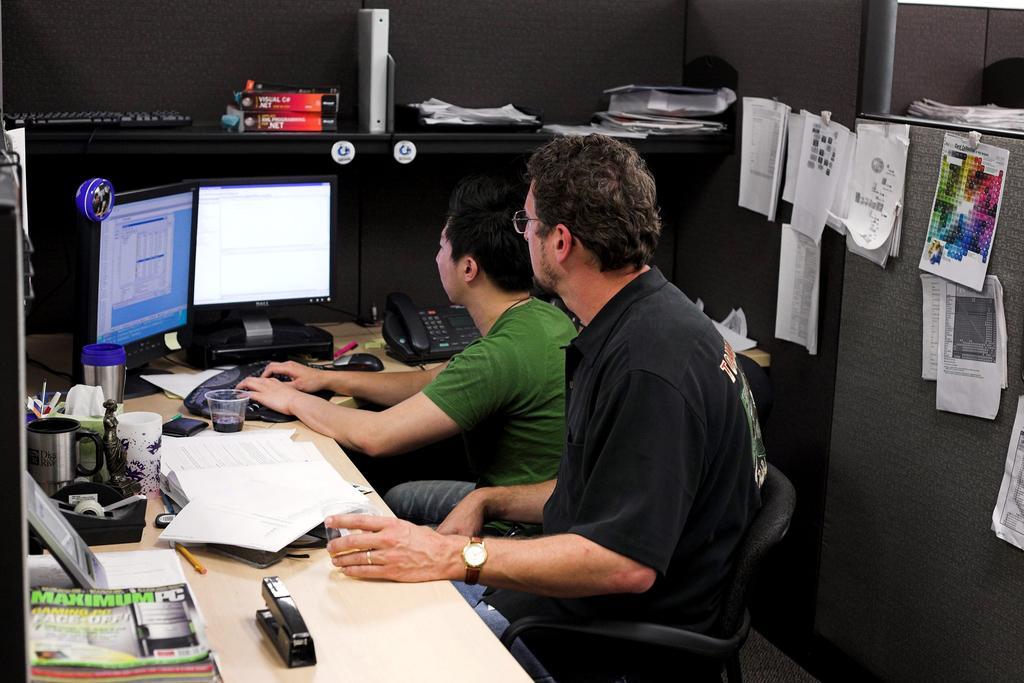How would you summarize this image in a sentence or two? This image is clicked inside the room There are two persons sitting in the chairs. To the left, there is a table on which some books, papers, and monitors are kept. To the right, there is a wall to which some papers are hanged with the clips. 